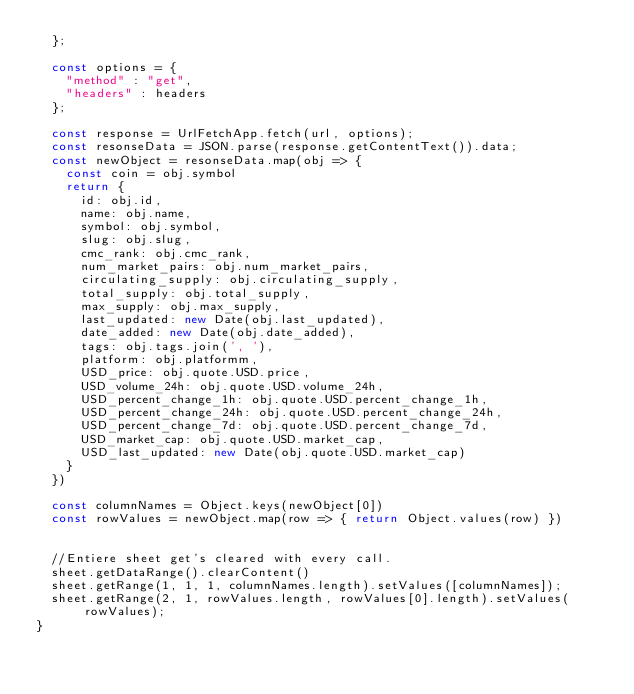<code> <loc_0><loc_0><loc_500><loc_500><_JavaScript_>  };
  
  const options = {
    "method" : "get",
    "headers" : headers 
  };

  const response = UrlFetchApp.fetch(url, options);
  const resonseData = JSON.parse(response.getContentText()).data;
  const newObject = resonseData.map(obj => {
    const coin = obj.symbol
    return {
      id: obj.id,
      name: obj.name,
      symbol: obj.symbol,
      slug: obj.slug,
      cmc_rank: obj.cmc_rank,
      num_market_pairs: obj.num_market_pairs,
      circulating_supply: obj.circulating_supply,
      total_supply: obj.total_supply,
      max_supply: obj.max_supply,
      last_updated: new Date(obj.last_updated),
      date_added: new Date(obj.date_added),
      tags: obj.tags.join(', '),
      platform: obj.platformm,
      USD_price: obj.quote.USD.price,
      USD_volume_24h: obj.quote.USD.volume_24h,
      USD_percent_change_1h: obj.quote.USD.percent_change_1h,
      USD_percent_change_24h: obj.quote.USD.percent_change_24h,
      USD_percent_change_7d: obj.quote.USD.percent_change_7d,
      USD_market_cap: obj.quote.USD.market_cap,
      USD_last_updated: new Date(obj.quote.USD.market_cap)
    }
  })

  const columnNames = Object.keys(newObject[0])
  const rowValues = newObject.map(row => { return Object.values(row) })


  //Entiere sheet get's cleared with every call.
  sheet.getDataRange().clearContent()
  sheet.getRange(1, 1, 1, columnNames.length).setValues([columnNames]);
  sheet.getRange(2, 1, rowValues.length, rowValues[0].length).setValues(rowValues);
}</code> 